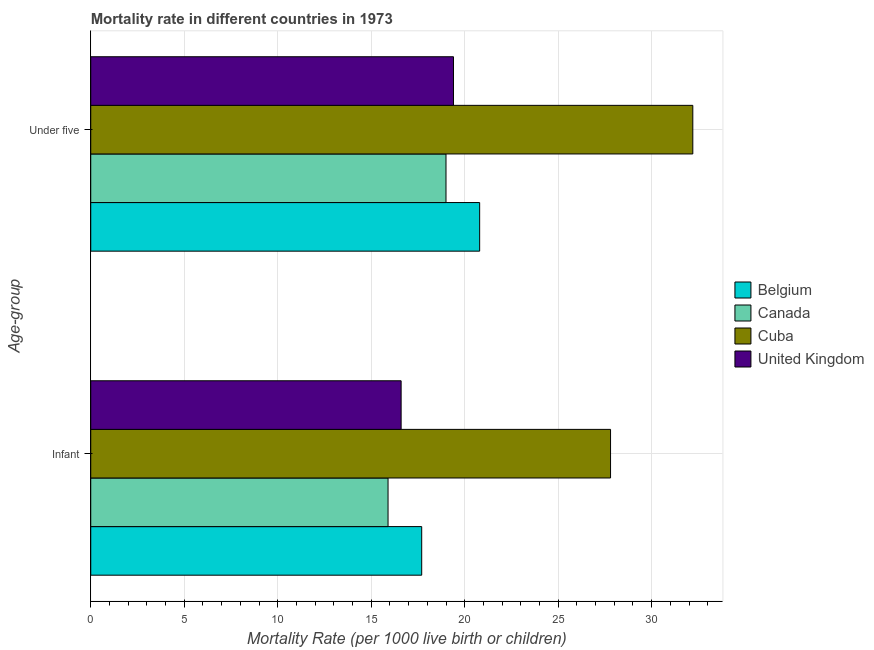How many different coloured bars are there?
Provide a succinct answer. 4. How many groups of bars are there?
Make the answer very short. 2. Are the number of bars on each tick of the Y-axis equal?
Offer a very short reply. Yes. How many bars are there on the 1st tick from the bottom?
Provide a short and direct response. 4. What is the label of the 2nd group of bars from the top?
Offer a terse response. Infant. Across all countries, what is the maximum infant mortality rate?
Keep it short and to the point. 27.8. In which country was the infant mortality rate maximum?
Keep it short and to the point. Cuba. What is the difference between the infant mortality rate in United Kingdom and that in Belgium?
Your answer should be very brief. -1.1. What is the difference between the infant mortality rate in Belgium and the under-5 mortality rate in Canada?
Provide a succinct answer. -1.3. What is the average under-5 mortality rate per country?
Make the answer very short. 22.85. What is the difference between the under-5 mortality rate and infant mortality rate in Cuba?
Your response must be concise. 4.4. In how many countries, is the under-5 mortality rate greater than 7 ?
Provide a short and direct response. 4. What is the ratio of the under-5 mortality rate in Cuba to that in United Kingdom?
Provide a succinct answer. 1.66. Is the infant mortality rate in United Kingdom less than that in Cuba?
Offer a very short reply. Yes. In how many countries, is the under-5 mortality rate greater than the average under-5 mortality rate taken over all countries?
Provide a succinct answer. 1. What does the 1st bar from the top in Under five represents?
Ensure brevity in your answer.  United Kingdom. Are the values on the major ticks of X-axis written in scientific E-notation?
Your answer should be compact. No. Does the graph contain any zero values?
Offer a very short reply. No. Where does the legend appear in the graph?
Your answer should be compact. Center right. What is the title of the graph?
Your answer should be compact. Mortality rate in different countries in 1973. What is the label or title of the X-axis?
Make the answer very short. Mortality Rate (per 1000 live birth or children). What is the label or title of the Y-axis?
Your answer should be compact. Age-group. What is the Mortality Rate (per 1000 live birth or children) of Belgium in Infant?
Give a very brief answer. 17.7. What is the Mortality Rate (per 1000 live birth or children) in Canada in Infant?
Make the answer very short. 15.9. What is the Mortality Rate (per 1000 live birth or children) of Cuba in Infant?
Provide a succinct answer. 27.8. What is the Mortality Rate (per 1000 live birth or children) in Belgium in Under five?
Provide a succinct answer. 20.8. What is the Mortality Rate (per 1000 live birth or children) in Cuba in Under five?
Your answer should be compact. 32.2. What is the Mortality Rate (per 1000 live birth or children) in United Kingdom in Under five?
Give a very brief answer. 19.4. Across all Age-group, what is the maximum Mortality Rate (per 1000 live birth or children) in Belgium?
Your answer should be compact. 20.8. Across all Age-group, what is the maximum Mortality Rate (per 1000 live birth or children) of Cuba?
Provide a short and direct response. 32.2. Across all Age-group, what is the maximum Mortality Rate (per 1000 live birth or children) of United Kingdom?
Ensure brevity in your answer.  19.4. Across all Age-group, what is the minimum Mortality Rate (per 1000 live birth or children) in Belgium?
Offer a very short reply. 17.7. Across all Age-group, what is the minimum Mortality Rate (per 1000 live birth or children) of Cuba?
Your answer should be very brief. 27.8. What is the total Mortality Rate (per 1000 live birth or children) in Belgium in the graph?
Make the answer very short. 38.5. What is the total Mortality Rate (per 1000 live birth or children) in Canada in the graph?
Offer a terse response. 34.9. What is the total Mortality Rate (per 1000 live birth or children) of Cuba in the graph?
Your answer should be compact. 60. What is the difference between the Mortality Rate (per 1000 live birth or children) of Belgium in Infant and that in Under five?
Provide a short and direct response. -3.1. What is the difference between the Mortality Rate (per 1000 live birth or children) of United Kingdom in Infant and that in Under five?
Provide a succinct answer. -2.8. What is the difference between the Mortality Rate (per 1000 live birth or children) of Belgium in Infant and the Mortality Rate (per 1000 live birth or children) of Canada in Under five?
Your response must be concise. -1.3. What is the difference between the Mortality Rate (per 1000 live birth or children) in Belgium in Infant and the Mortality Rate (per 1000 live birth or children) in United Kingdom in Under five?
Your response must be concise. -1.7. What is the difference between the Mortality Rate (per 1000 live birth or children) in Canada in Infant and the Mortality Rate (per 1000 live birth or children) in Cuba in Under five?
Provide a short and direct response. -16.3. What is the difference between the Mortality Rate (per 1000 live birth or children) in Canada in Infant and the Mortality Rate (per 1000 live birth or children) in United Kingdom in Under five?
Provide a short and direct response. -3.5. What is the average Mortality Rate (per 1000 live birth or children) in Belgium per Age-group?
Your response must be concise. 19.25. What is the average Mortality Rate (per 1000 live birth or children) of Canada per Age-group?
Keep it short and to the point. 17.45. What is the average Mortality Rate (per 1000 live birth or children) of United Kingdom per Age-group?
Your answer should be very brief. 18. What is the difference between the Mortality Rate (per 1000 live birth or children) of Belgium and Mortality Rate (per 1000 live birth or children) of Canada in Infant?
Keep it short and to the point. 1.8. What is the difference between the Mortality Rate (per 1000 live birth or children) of Belgium and Mortality Rate (per 1000 live birth or children) of Cuba in Infant?
Make the answer very short. -10.1. What is the difference between the Mortality Rate (per 1000 live birth or children) in Belgium and Mortality Rate (per 1000 live birth or children) in United Kingdom in Infant?
Your answer should be very brief. 1.1. What is the difference between the Mortality Rate (per 1000 live birth or children) in Canada and Mortality Rate (per 1000 live birth or children) in United Kingdom in Infant?
Your response must be concise. -0.7. What is the difference between the Mortality Rate (per 1000 live birth or children) of Belgium and Mortality Rate (per 1000 live birth or children) of Canada in Under five?
Provide a succinct answer. 1.8. What is the difference between the Mortality Rate (per 1000 live birth or children) of Belgium and Mortality Rate (per 1000 live birth or children) of Cuba in Under five?
Your answer should be compact. -11.4. What is the ratio of the Mortality Rate (per 1000 live birth or children) in Belgium in Infant to that in Under five?
Offer a very short reply. 0.85. What is the ratio of the Mortality Rate (per 1000 live birth or children) in Canada in Infant to that in Under five?
Give a very brief answer. 0.84. What is the ratio of the Mortality Rate (per 1000 live birth or children) in Cuba in Infant to that in Under five?
Offer a very short reply. 0.86. What is the ratio of the Mortality Rate (per 1000 live birth or children) of United Kingdom in Infant to that in Under five?
Offer a terse response. 0.86. What is the difference between the highest and the second highest Mortality Rate (per 1000 live birth or children) of Belgium?
Ensure brevity in your answer.  3.1. What is the difference between the highest and the second highest Mortality Rate (per 1000 live birth or children) in Canada?
Your answer should be compact. 3.1. What is the difference between the highest and the second highest Mortality Rate (per 1000 live birth or children) of Cuba?
Give a very brief answer. 4.4. What is the difference between the highest and the second highest Mortality Rate (per 1000 live birth or children) in United Kingdom?
Provide a succinct answer. 2.8. What is the difference between the highest and the lowest Mortality Rate (per 1000 live birth or children) in Cuba?
Make the answer very short. 4.4. What is the difference between the highest and the lowest Mortality Rate (per 1000 live birth or children) of United Kingdom?
Your response must be concise. 2.8. 